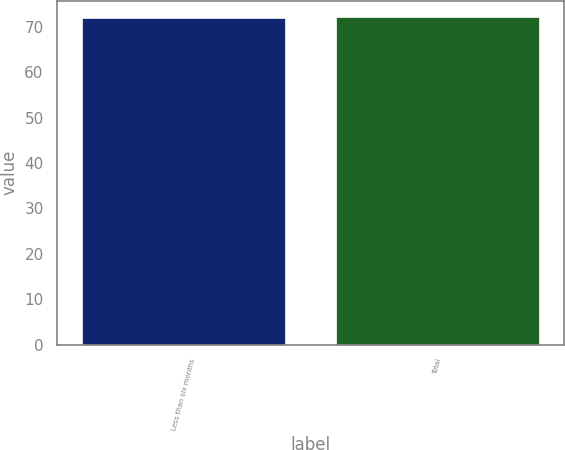Convert chart. <chart><loc_0><loc_0><loc_500><loc_500><bar_chart><fcel>Less than six months<fcel>Total<nl><fcel>72<fcel>72.1<nl></chart> 